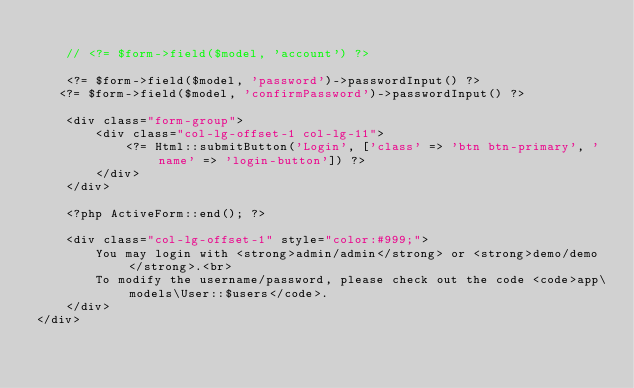Convert code to text. <code><loc_0><loc_0><loc_500><loc_500><_PHP_>
    // <?= $form->field($model, 'account') ?>

    <?= $form->field($model, 'password')->passwordInput() ?>
	 <?= $form->field($model, 'confirmPassword')->passwordInput() ?>

    <div class="form-group">
        <div class="col-lg-offset-1 col-lg-11">
            <?= Html::submitButton('Login', ['class' => 'btn btn-primary', 'name' => 'login-button']) ?>
        </div>
    </div>

    <?php ActiveForm::end(); ?>

    <div class="col-lg-offset-1" style="color:#999;">
        You may login with <strong>admin/admin</strong> or <strong>demo/demo</strong>.<br>
        To modify the username/password, please check out the code <code>app\models\User::$users</code>.
    </div>
</div>
</code> 